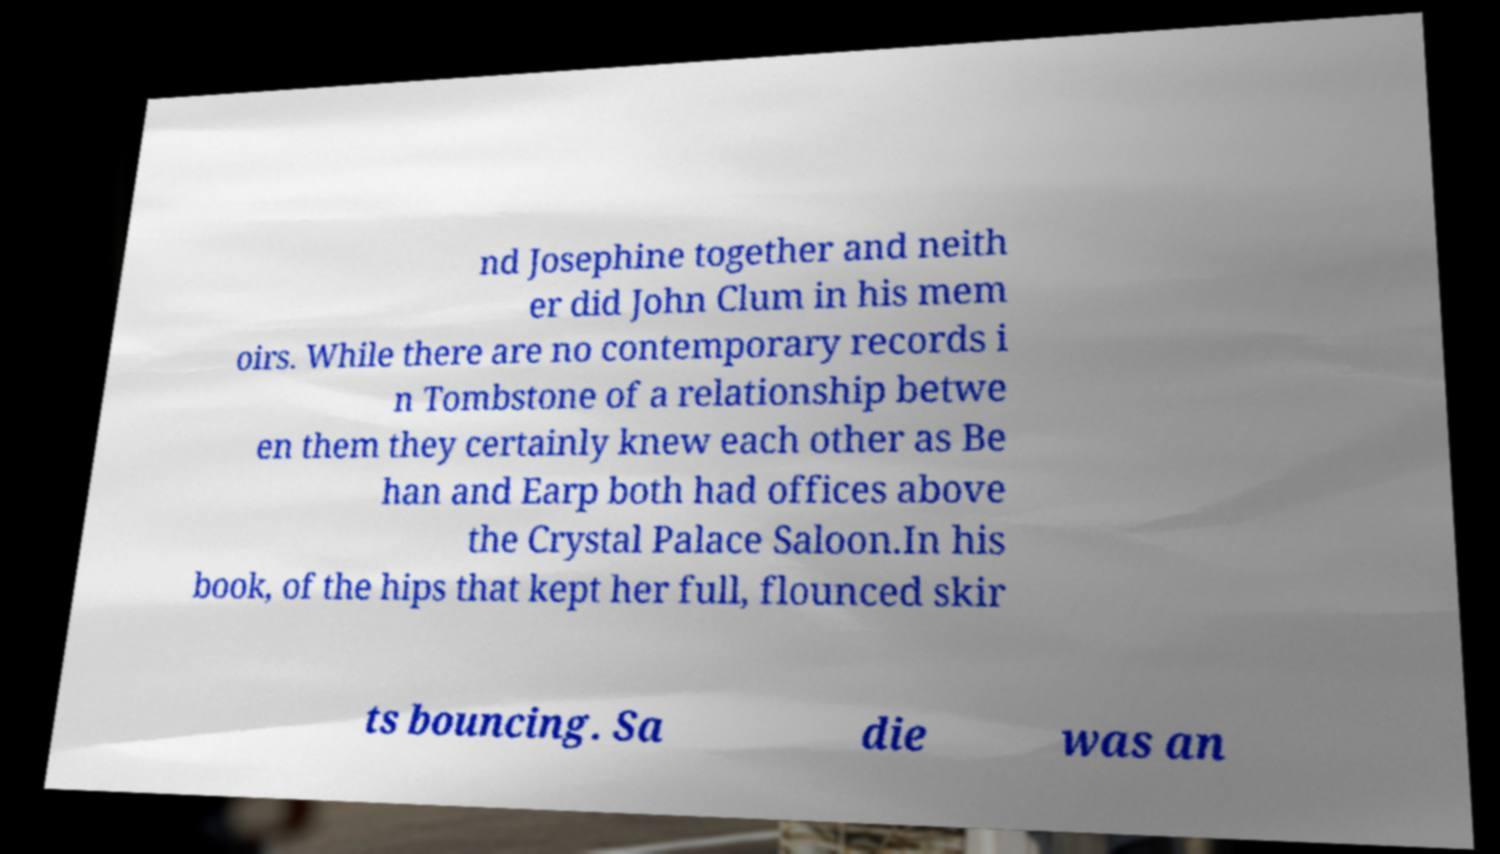Can you accurately transcribe the text from the provided image for me? nd Josephine together and neith er did John Clum in his mem oirs. While there are no contemporary records i n Tombstone of a relationship betwe en them they certainly knew each other as Be han and Earp both had offices above the Crystal Palace Saloon.In his book, of the hips that kept her full, flounced skir ts bouncing. Sa die was an 